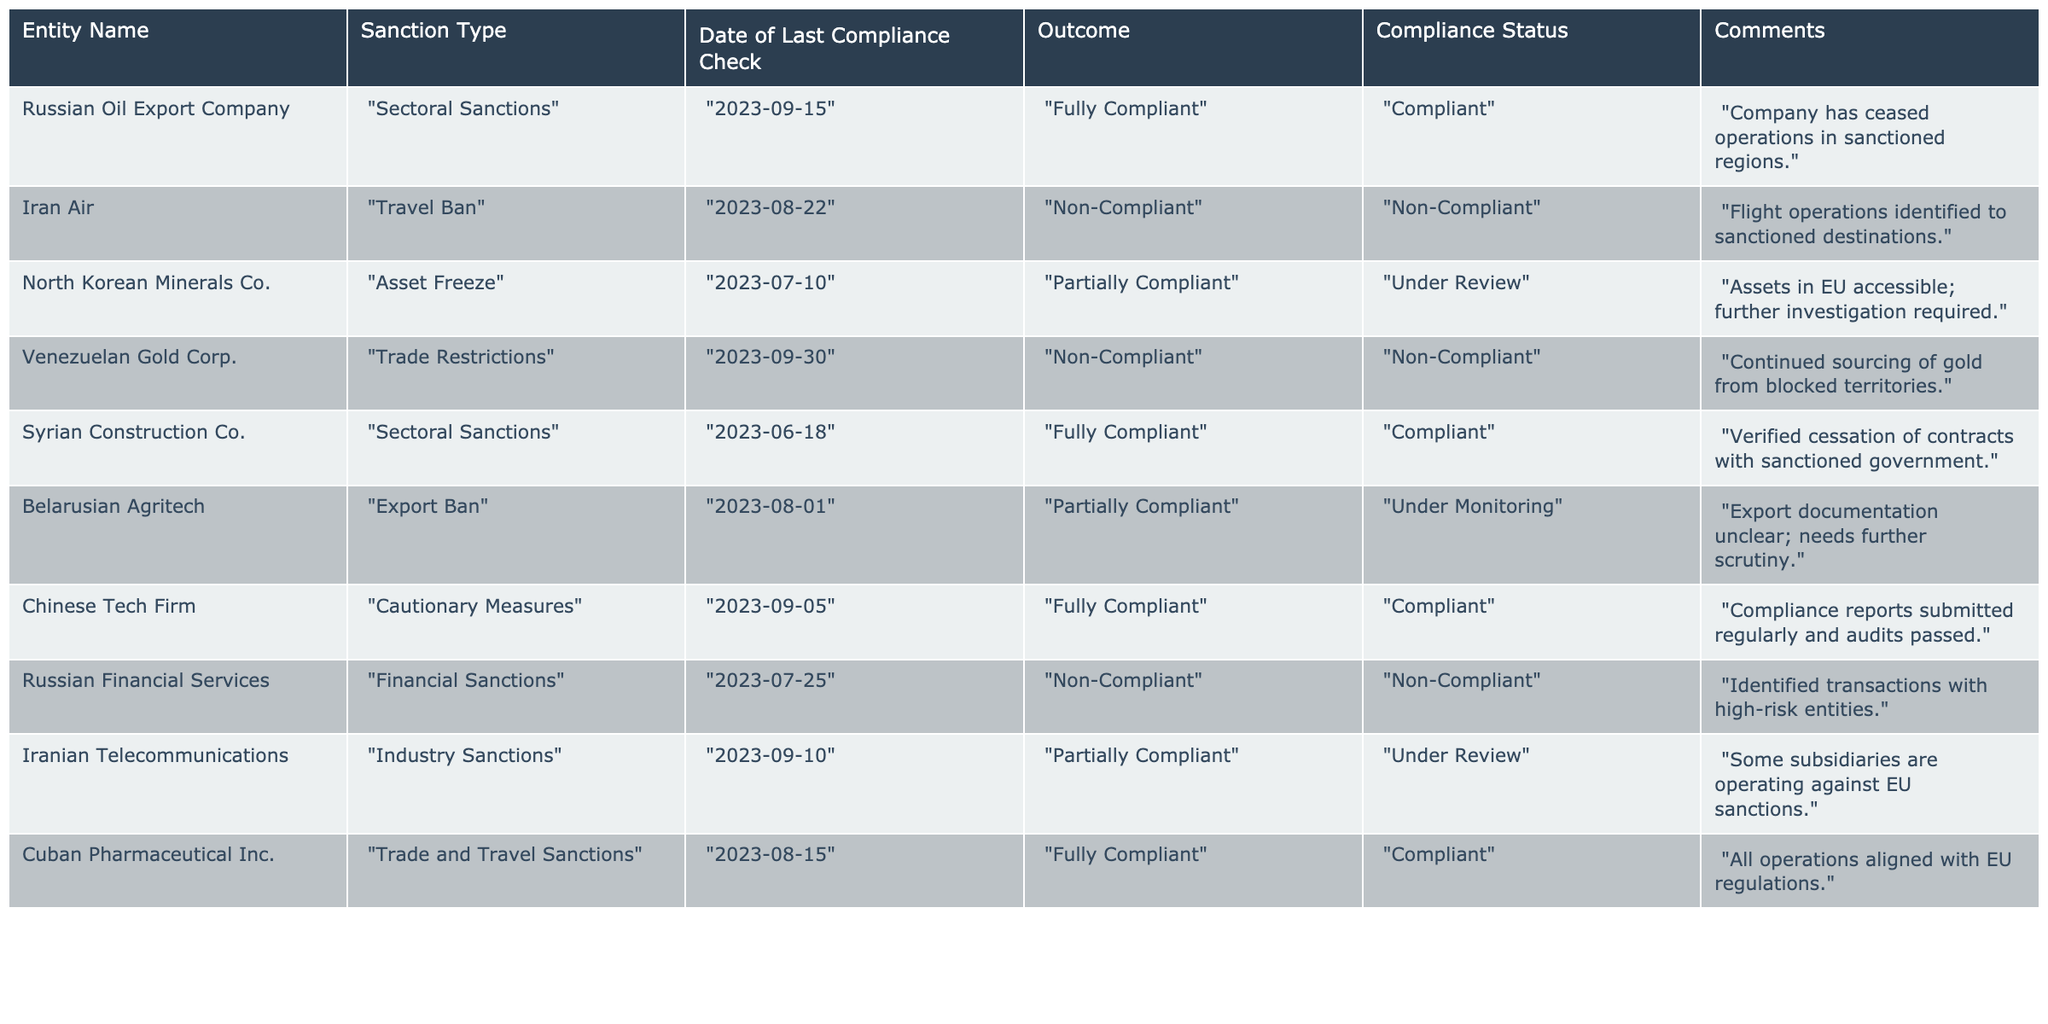What is the compliance status of the "Chinese Tech Firm"? The table shows that the compliance status for "Chinese Tech Firm" is listed as "Compliant".
Answer: Compliant Which entity is under review for compliance with sanctions? The table indicates that "North Korean Minerals Co." and "Iranian Telecommunications" are both marked as "Under Review".
Answer: North Korean Minerals Co. and Iranian Telecommunications How many entities are fully compliant? By reviewing the table, we can count "Russian Oil Export Company", "Syrian Construction Co.", "Chinese Tech Firm", and "Cuban Pharmaceutical Inc." as fully compliant. That totals four entities.
Answer: 4 Is "Iran Air" compliant? The table explicitly states that "Iran Air" has a compliance status of "Non-Compliant".
Answer: No Which entity had its last compliance check on September 10, 2023? The table lists "Iranian Telecommunications" with the date of the last compliance check as September 10, 2023.
Answer: Iranian Telecommunications What is the outcome of the compliance check for "Venezuelan Gold Corp."? The table indicates that the outcome of the compliance check for "Venezuelan Gold Corp." is "Non-Compliant".
Answer: Non-Compliant How many entities are non-compliant? By counting the outcomes in the table, the non-compliant entities are "Iran Air", "Venezuelan Gold Corp.", and "Russian Financial Services", totaling three.
Answer: 3 Which sanctioned entity ceased operations in sanctioned regions? The comments for "Russian Oil Export Company" state that it has ceased operations in sanctioned regions, indicating compliance.
Answer: Russian Oil Export Company What is the primary reason for the non-compliance of "Iran Air"? The table states that the reason for "Iran Air" being non-compliant is that flight operations were identified to sanctioned destinations.
Answer: Flight operations to sanctioned destinations Compare the outcomes of "North Korean Minerals Co." and "Belarusian Agritech". Which company had a better compliance outcome? "North Korean Minerals Co." is marked as "Partially Compliant" and is "Under Review", while "Belarusian Agritech" is also "Partially Compliant" but marked as "Under Monitoring". This indicates they are both at a similar compliance level, but the monitoring implies closer scrutiny.
Answer: Similar compliance outcomes 